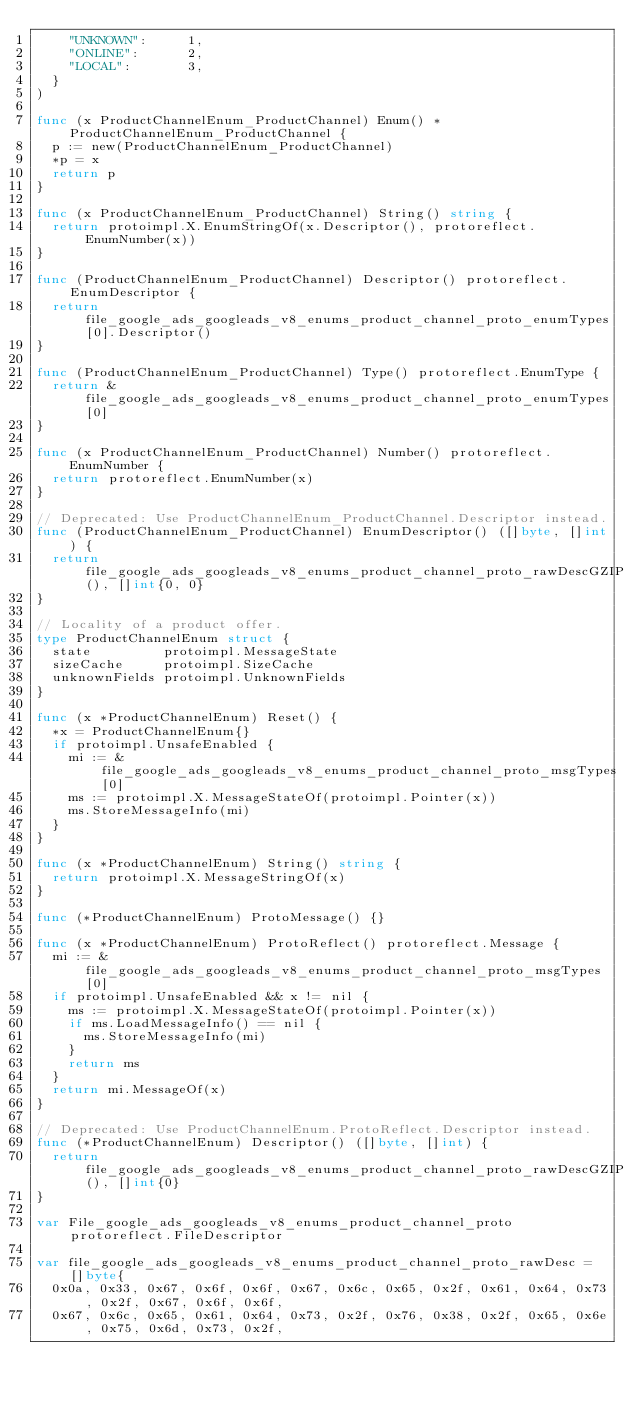Convert code to text. <code><loc_0><loc_0><loc_500><loc_500><_Go_>		"UNKNOWN":     1,
		"ONLINE":      2,
		"LOCAL":       3,
	}
)

func (x ProductChannelEnum_ProductChannel) Enum() *ProductChannelEnum_ProductChannel {
	p := new(ProductChannelEnum_ProductChannel)
	*p = x
	return p
}

func (x ProductChannelEnum_ProductChannel) String() string {
	return protoimpl.X.EnumStringOf(x.Descriptor(), protoreflect.EnumNumber(x))
}

func (ProductChannelEnum_ProductChannel) Descriptor() protoreflect.EnumDescriptor {
	return file_google_ads_googleads_v8_enums_product_channel_proto_enumTypes[0].Descriptor()
}

func (ProductChannelEnum_ProductChannel) Type() protoreflect.EnumType {
	return &file_google_ads_googleads_v8_enums_product_channel_proto_enumTypes[0]
}

func (x ProductChannelEnum_ProductChannel) Number() protoreflect.EnumNumber {
	return protoreflect.EnumNumber(x)
}

// Deprecated: Use ProductChannelEnum_ProductChannel.Descriptor instead.
func (ProductChannelEnum_ProductChannel) EnumDescriptor() ([]byte, []int) {
	return file_google_ads_googleads_v8_enums_product_channel_proto_rawDescGZIP(), []int{0, 0}
}

// Locality of a product offer.
type ProductChannelEnum struct {
	state         protoimpl.MessageState
	sizeCache     protoimpl.SizeCache
	unknownFields protoimpl.UnknownFields
}

func (x *ProductChannelEnum) Reset() {
	*x = ProductChannelEnum{}
	if protoimpl.UnsafeEnabled {
		mi := &file_google_ads_googleads_v8_enums_product_channel_proto_msgTypes[0]
		ms := protoimpl.X.MessageStateOf(protoimpl.Pointer(x))
		ms.StoreMessageInfo(mi)
	}
}

func (x *ProductChannelEnum) String() string {
	return protoimpl.X.MessageStringOf(x)
}

func (*ProductChannelEnum) ProtoMessage() {}

func (x *ProductChannelEnum) ProtoReflect() protoreflect.Message {
	mi := &file_google_ads_googleads_v8_enums_product_channel_proto_msgTypes[0]
	if protoimpl.UnsafeEnabled && x != nil {
		ms := protoimpl.X.MessageStateOf(protoimpl.Pointer(x))
		if ms.LoadMessageInfo() == nil {
			ms.StoreMessageInfo(mi)
		}
		return ms
	}
	return mi.MessageOf(x)
}

// Deprecated: Use ProductChannelEnum.ProtoReflect.Descriptor instead.
func (*ProductChannelEnum) Descriptor() ([]byte, []int) {
	return file_google_ads_googleads_v8_enums_product_channel_proto_rawDescGZIP(), []int{0}
}

var File_google_ads_googleads_v8_enums_product_channel_proto protoreflect.FileDescriptor

var file_google_ads_googleads_v8_enums_product_channel_proto_rawDesc = []byte{
	0x0a, 0x33, 0x67, 0x6f, 0x6f, 0x67, 0x6c, 0x65, 0x2f, 0x61, 0x64, 0x73, 0x2f, 0x67, 0x6f, 0x6f,
	0x67, 0x6c, 0x65, 0x61, 0x64, 0x73, 0x2f, 0x76, 0x38, 0x2f, 0x65, 0x6e, 0x75, 0x6d, 0x73, 0x2f,</code> 